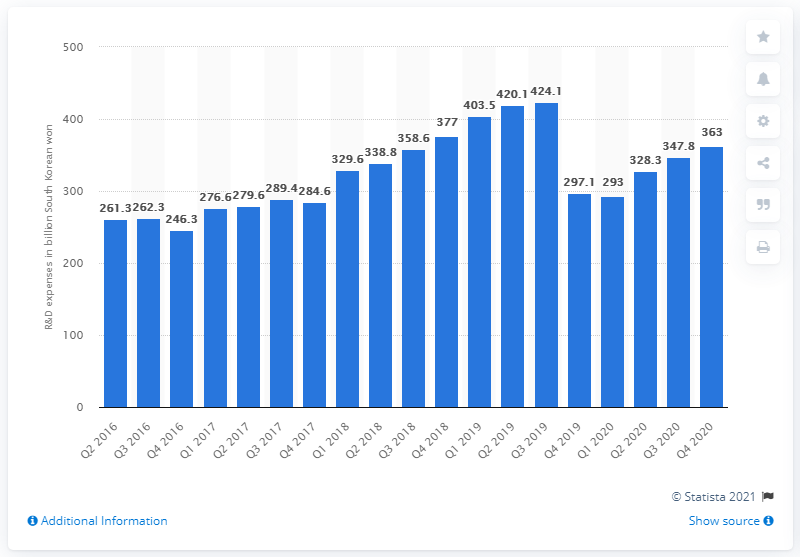Mention a couple of crucial points in this snapshot. Naver spent 363 million South Korean won on research and development in the fourth quarter of 2020. 